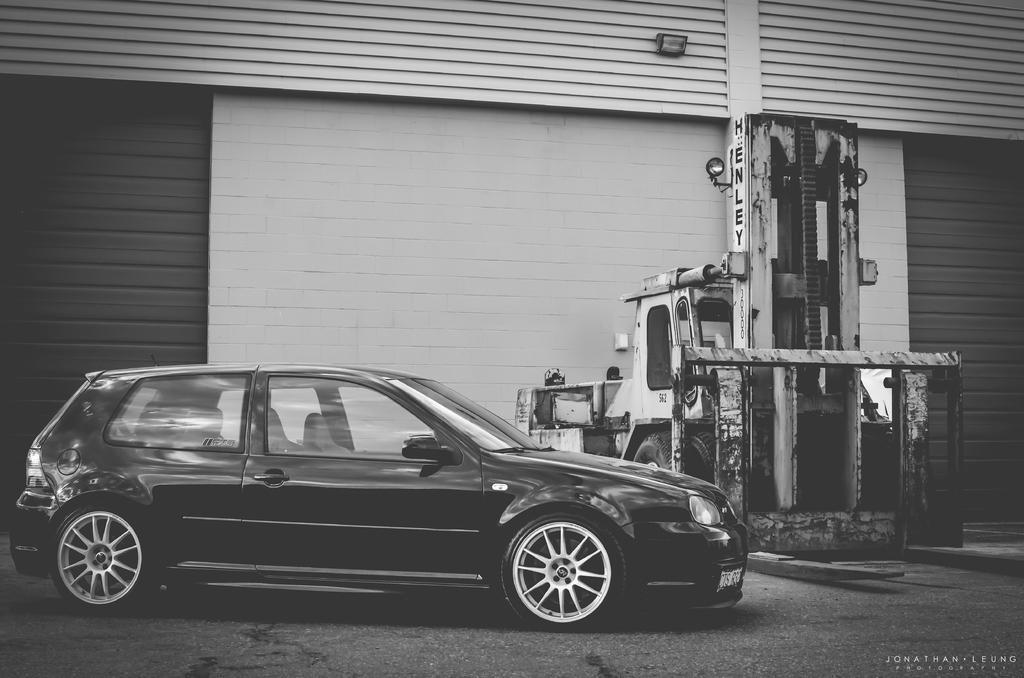Please provide a concise description of this image. In the foreground of this image, there is a car on the ground and in the background, there is a vehicle near a wall and on top there is a wall and a light on it. 